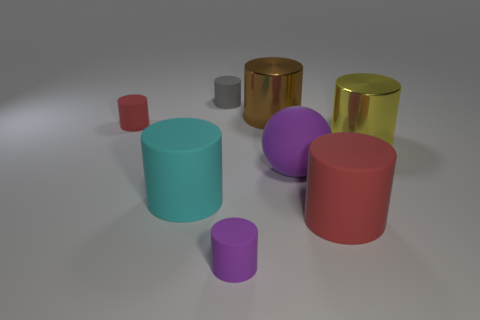The large matte ball is what color?
Provide a short and direct response. Purple. How many things are either metal cylinders or big objects?
Make the answer very short. 5. There is a red thing that is in front of the red thing that is left of the large purple thing; what is its shape?
Your response must be concise. Cylinder. How many other things are made of the same material as the brown cylinder?
Your answer should be compact. 1. Is the material of the cyan cylinder the same as the large red thing in front of the ball?
Provide a succinct answer. Yes. How many things are purple things to the left of the purple ball or small matte things behind the big cyan thing?
Provide a succinct answer. 3. How many other objects are there of the same color as the large sphere?
Provide a short and direct response. 1. Are there more large brown things that are in front of the big cyan thing than cyan cylinders in front of the purple cylinder?
Keep it short and to the point. No. Are there any other things that are the same size as the purple matte ball?
Your answer should be very brief. Yes. What number of cylinders are gray things or big red things?
Your answer should be compact. 2. 